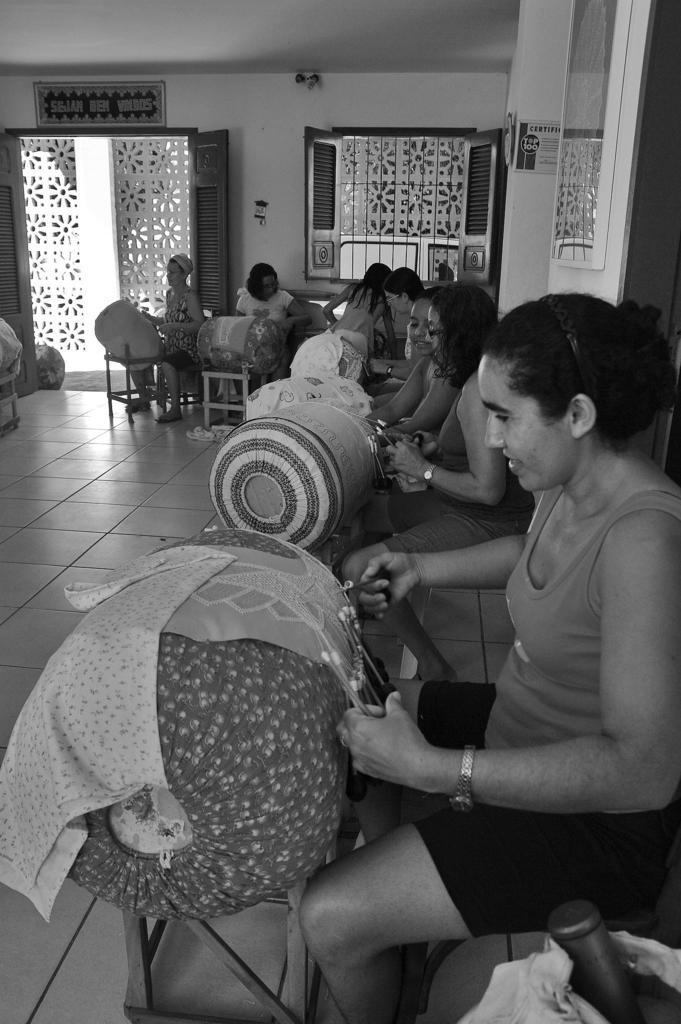Can you describe this image briefly? The picture is from a room. In the picture there are many women weaving the cloth. In the foreground of the picture there is a woman sitting on stool and stitching something. In the background on the wall there is a window and a door. 